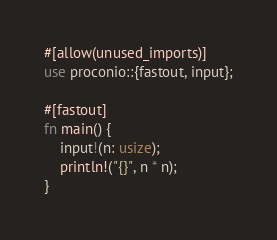Convert code to text. <code><loc_0><loc_0><loc_500><loc_500><_Rust_>#[allow(unused_imports)]
use proconio::{fastout, input};

#[fastout]
fn main() {
    input!(n: usize);
    println!("{}", n * n);
}
</code> 